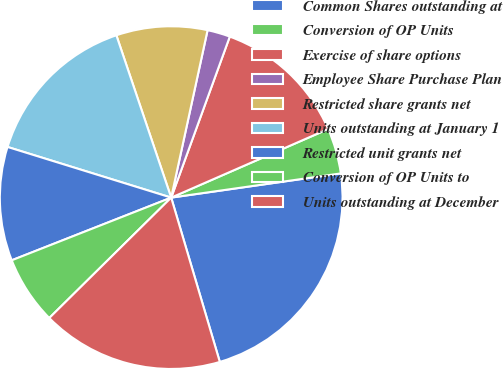Convert chart. <chart><loc_0><loc_0><loc_500><loc_500><pie_chart><fcel>Common Shares outstanding at<fcel>Conversion of OP Units<fcel>Exercise of share options<fcel>Employee Share Purchase Plan<fcel>Restricted share grants net<fcel>Units outstanding at January 1<fcel>Restricted unit grants net<fcel>Conversion of OP Units to<fcel>Units outstanding at December<nl><fcel>22.68%<fcel>4.3%<fcel>12.89%<fcel>2.15%<fcel>8.59%<fcel>15.04%<fcel>10.74%<fcel>6.44%<fcel>17.18%<nl></chart> 